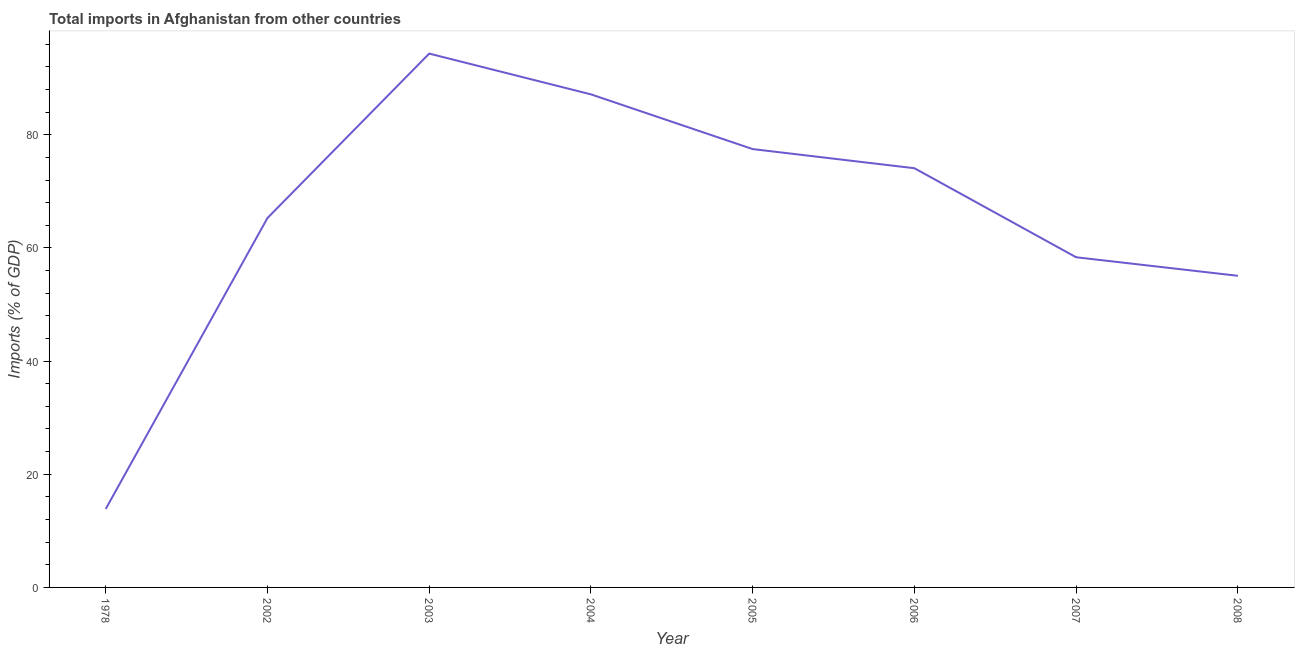What is the total imports in 2008?
Provide a short and direct response. 55.07. Across all years, what is the maximum total imports?
Provide a succinct answer. 94.34. Across all years, what is the minimum total imports?
Offer a very short reply. 13.87. In which year was the total imports maximum?
Ensure brevity in your answer.  2003. In which year was the total imports minimum?
Your answer should be very brief. 1978. What is the sum of the total imports?
Provide a short and direct response. 525.62. What is the difference between the total imports in 2004 and 2005?
Ensure brevity in your answer.  9.67. What is the average total imports per year?
Offer a very short reply. 65.7. What is the median total imports?
Offer a terse response. 69.69. In how many years, is the total imports greater than 92 %?
Make the answer very short. 1. What is the ratio of the total imports in 2007 to that in 2008?
Provide a succinct answer. 1.06. Is the total imports in 2003 less than that in 2007?
Ensure brevity in your answer.  No. Is the difference between the total imports in 2005 and 2006 greater than the difference between any two years?
Make the answer very short. No. What is the difference between the highest and the second highest total imports?
Your answer should be compact. 7.2. Is the sum of the total imports in 1978 and 2004 greater than the maximum total imports across all years?
Your response must be concise. Yes. What is the difference between the highest and the lowest total imports?
Give a very brief answer. 80.47. In how many years, is the total imports greater than the average total imports taken over all years?
Make the answer very short. 4. Does the total imports monotonically increase over the years?
Offer a terse response. No. How many lines are there?
Ensure brevity in your answer.  1. How many years are there in the graph?
Provide a short and direct response. 8. What is the difference between two consecutive major ticks on the Y-axis?
Offer a terse response. 20. Are the values on the major ticks of Y-axis written in scientific E-notation?
Ensure brevity in your answer.  No. What is the title of the graph?
Provide a succinct answer. Total imports in Afghanistan from other countries. What is the label or title of the Y-axis?
Your answer should be very brief. Imports (% of GDP). What is the Imports (% of GDP) in 1978?
Your response must be concise. 13.87. What is the Imports (% of GDP) of 2002?
Keep it short and to the point. 65.29. What is the Imports (% of GDP) in 2003?
Offer a terse response. 94.34. What is the Imports (% of GDP) in 2004?
Your answer should be compact. 87.14. What is the Imports (% of GDP) of 2005?
Your answer should be compact. 77.47. What is the Imports (% of GDP) in 2006?
Offer a terse response. 74.09. What is the Imports (% of GDP) of 2007?
Offer a very short reply. 58.35. What is the Imports (% of GDP) in 2008?
Offer a terse response. 55.07. What is the difference between the Imports (% of GDP) in 1978 and 2002?
Make the answer very short. -51.42. What is the difference between the Imports (% of GDP) in 1978 and 2003?
Keep it short and to the point. -80.47. What is the difference between the Imports (% of GDP) in 1978 and 2004?
Offer a very short reply. -73.27. What is the difference between the Imports (% of GDP) in 1978 and 2005?
Your answer should be compact. -63.6. What is the difference between the Imports (% of GDP) in 1978 and 2006?
Provide a short and direct response. -60.21. What is the difference between the Imports (% of GDP) in 1978 and 2007?
Provide a succinct answer. -44.48. What is the difference between the Imports (% of GDP) in 1978 and 2008?
Provide a succinct answer. -41.2. What is the difference between the Imports (% of GDP) in 2002 and 2003?
Your response must be concise. -29.06. What is the difference between the Imports (% of GDP) in 2002 and 2004?
Offer a very short reply. -21.85. What is the difference between the Imports (% of GDP) in 2002 and 2005?
Provide a short and direct response. -12.18. What is the difference between the Imports (% of GDP) in 2002 and 2006?
Keep it short and to the point. -8.8. What is the difference between the Imports (% of GDP) in 2002 and 2007?
Ensure brevity in your answer.  6.94. What is the difference between the Imports (% of GDP) in 2002 and 2008?
Provide a short and direct response. 10.22. What is the difference between the Imports (% of GDP) in 2003 and 2004?
Give a very brief answer. 7.2. What is the difference between the Imports (% of GDP) in 2003 and 2005?
Your response must be concise. 16.88. What is the difference between the Imports (% of GDP) in 2003 and 2006?
Your answer should be compact. 20.26. What is the difference between the Imports (% of GDP) in 2003 and 2007?
Your answer should be compact. 35.99. What is the difference between the Imports (% of GDP) in 2003 and 2008?
Offer a terse response. 39.27. What is the difference between the Imports (% of GDP) in 2004 and 2005?
Keep it short and to the point. 9.67. What is the difference between the Imports (% of GDP) in 2004 and 2006?
Keep it short and to the point. 13.05. What is the difference between the Imports (% of GDP) in 2004 and 2007?
Offer a very short reply. 28.79. What is the difference between the Imports (% of GDP) in 2004 and 2008?
Your answer should be very brief. 32.07. What is the difference between the Imports (% of GDP) in 2005 and 2006?
Keep it short and to the point. 3.38. What is the difference between the Imports (% of GDP) in 2005 and 2007?
Give a very brief answer. 19.12. What is the difference between the Imports (% of GDP) in 2005 and 2008?
Make the answer very short. 22.39. What is the difference between the Imports (% of GDP) in 2006 and 2007?
Make the answer very short. 15.74. What is the difference between the Imports (% of GDP) in 2006 and 2008?
Provide a short and direct response. 19.01. What is the difference between the Imports (% of GDP) in 2007 and 2008?
Provide a short and direct response. 3.28. What is the ratio of the Imports (% of GDP) in 1978 to that in 2002?
Make the answer very short. 0.21. What is the ratio of the Imports (% of GDP) in 1978 to that in 2003?
Offer a terse response. 0.15. What is the ratio of the Imports (% of GDP) in 1978 to that in 2004?
Your answer should be compact. 0.16. What is the ratio of the Imports (% of GDP) in 1978 to that in 2005?
Provide a succinct answer. 0.18. What is the ratio of the Imports (% of GDP) in 1978 to that in 2006?
Your answer should be compact. 0.19. What is the ratio of the Imports (% of GDP) in 1978 to that in 2007?
Your response must be concise. 0.24. What is the ratio of the Imports (% of GDP) in 1978 to that in 2008?
Keep it short and to the point. 0.25. What is the ratio of the Imports (% of GDP) in 2002 to that in 2003?
Your response must be concise. 0.69. What is the ratio of the Imports (% of GDP) in 2002 to that in 2004?
Your response must be concise. 0.75. What is the ratio of the Imports (% of GDP) in 2002 to that in 2005?
Keep it short and to the point. 0.84. What is the ratio of the Imports (% of GDP) in 2002 to that in 2006?
Your answer should be very brief. 0.88. What is the ratio of the Imports (% of GDP) in 2002 to that in 2007?
Give a very brief answer. 1.12. What is the ratio of the Imports (% of GDP) in 2002 to that in 2008?
Make the answer very short. 1.19. What is the ratio of the Imports (% of GDP) in 2003 to that in 2004?
Keep it short and to the point. 1.08. What is the ratio of the Imports (% of GDP) in 2003 to that in 2005?
Offer a terse response. 1.22. What is the ratio of the Imports (% of GDP) in 2003 to that in 2006?
Provide a succinct answer. 1.27. What is the ratio of the Imports (% of GDP) in 2003 to that in 2007?
Ensure brevity in your answer.  1.62. What is the ratio of the Imports (% of GDP) in 2003 to that in 2008?
Your response must be concise. 1.71. What is the ratio of the Imports (% of GDP) in 2004 to that in 2006?
Your response must be concise. 1.18. What is the ratio of the Imports (% of GDP) in 2004 to that in 2007?
Make the answer very short. 1.49. What is the ratio of the Imports (% of GDP) in 2004 to that in 2008?
Ensure brevity in your answer.  1.58. What is the ratio of the Imports (% of GDP) in 2005 to that in 2006?
Make the answer very short. 1.05. What is the ratio of the Imports (% of GDP) in 2005 to that in 2007?
Offer a very short reply. 1.33. What is the ratio of the Imports (% of GDP) in 2005 to that in 2008?
Provide a short and direct response. 1.41. What is the ratio of the Imports (% of GDP) in 2006 to that in 2007?
Your response must be concise. 1.27. What is the ratio of the Imports (% of GDP) in 2006 to that in 2008?
Keep it short and to the point. 1.34. What is the ratio of the Imports (% of GDP) in 2007 to that in 2008?
Offer a very short reply. 1.06. 